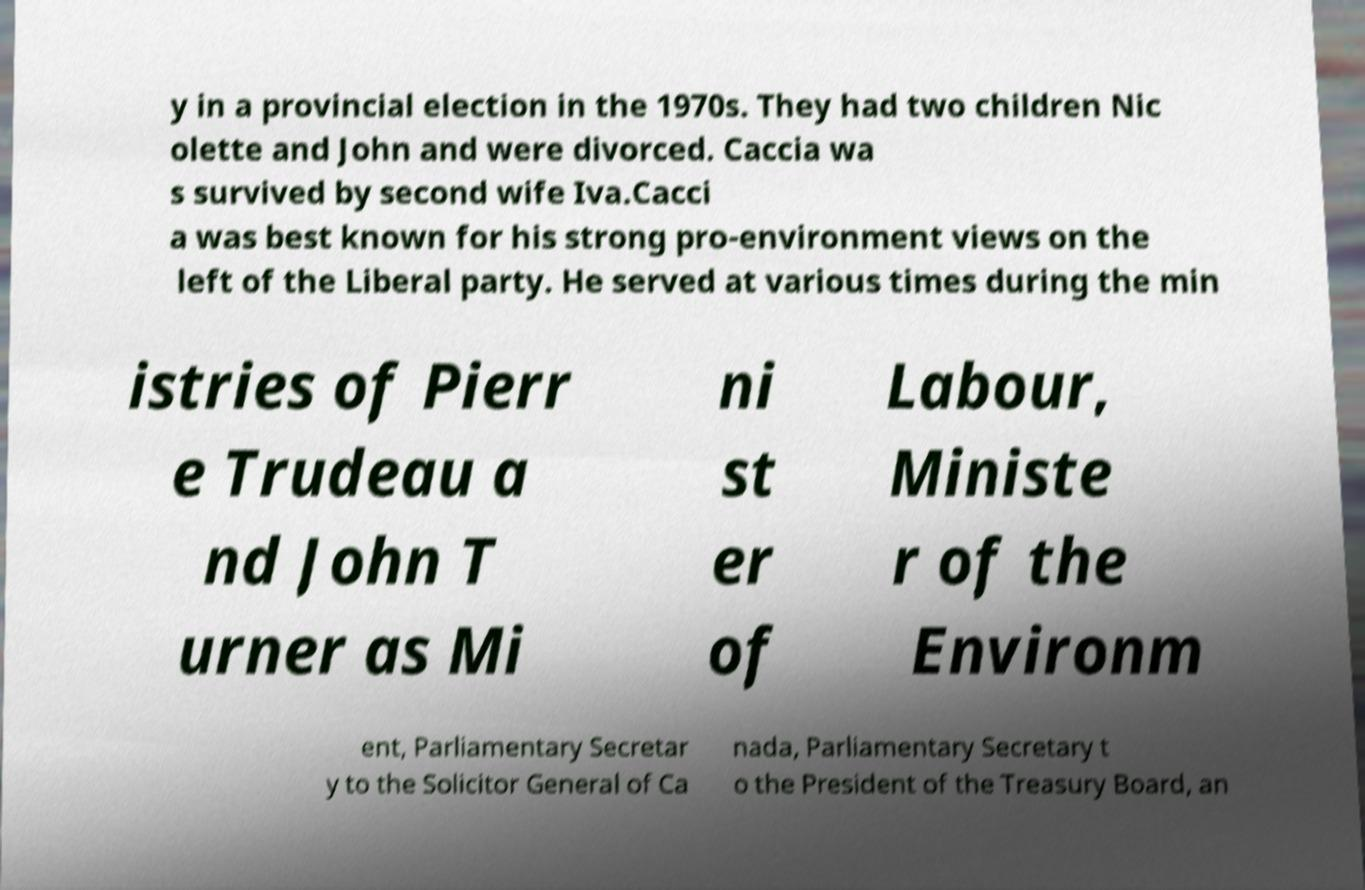Please identify and transcribe the text found in this image. y in a provincial election in the 1970s. They had two children Nic olette and John and were divorced. Caccia wa s survived by second wife Iva.Cacci a was best known for his strong pro-environment views on the left of the Liberal party. He served at various times during the min istries of Pierr e Trudeau a nd John T urner as Mi ni st er of Labour, Ministe r of the Environm ent, Parliamentary Secretar y to the Solicitor General of Ca nada, Parliamentary Secretary t o the President of the Treasury Board, an 